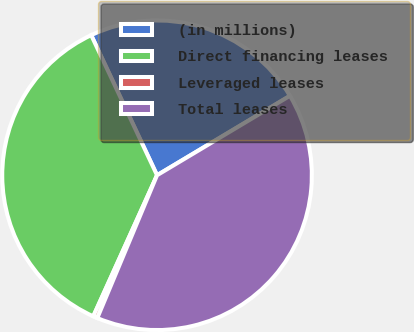Convert chart. <chart><loc_0><loc_0><loc_500><loc_500><pie_chart><fcel>(in millions)<fcel>Direct financing leases<fcel>Leveraged leases<fcel>Total leases<nl><fcel>23.42%<fcel>36.25%<fcel>0.45%<fcel>39.88%<nl></chart> 